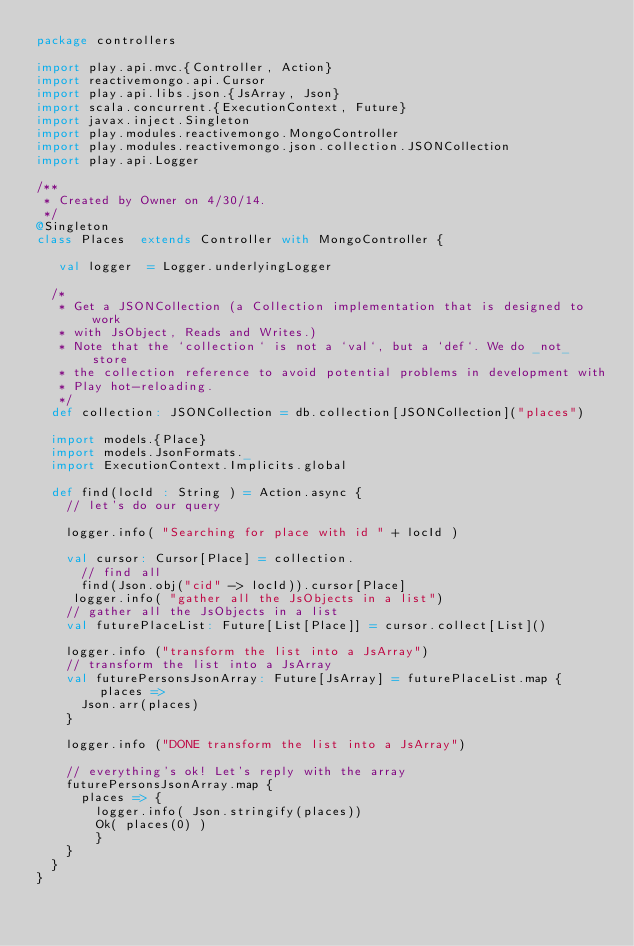Convert code to text. <code><loc_0><loc_0><loc_500><loc_500><_Scala_>package controllers

import play.api.mvc.{Controller, Action}
import reactivemongo.api.Cursor
import play.api.libs.json.{JsArray, Json}
import scala.concurrent.{ExecutionContext, Future}
import javax.inject.Singleton
import play.modules.reactivemongo.MongoController
import play.modules.reactivemongo.json.collection.JSONCollection
import play.api.Logger

/**
 * Created by Owner on 4/30/14.
 */
@Singleton
class Places  extends Controller with MongoController {

   val logger  = Logger.underlyingLogger

  /*
   * Get a JSONCollection (a Collection implementation that is designed to work
   * with JsObject, Reads and Writes.)
   * Note that the `collection` is not a `val`, but a `def`. We do _not_ store
   * the collection reference to avoid potential problems in development with
   * Play hot-reloading.
   */
  def collection: JSONCollection = db.collection[JSONCollection]("places")

  import models.{Place}
  import models.JsonFormats._
  import ExecutionContext.Implicits.global

  def find(locId : String ) = Action.async {
    // let's do our query

    logger.info( "Searching for place with id " + locId )

    val cursor: Cursor[Place] = collection.
      // find all
      find(Json.obj("cid" -> locId)).cursor[Place]
     logger.info( "gather all the JsObjects in a list")
    // gather all the JsObjects in a list
    val futurePlaceList: Future[List[Place]] = cursor.collect[List]()

    logger.info ("transform the list into a JsArray")
    // transform the list into a JsArray
    val futurePersonsJsonArray: Future[JsArray] = futurePlaceList.map { places =>
      Json.arr(places)
    }

    logger.info ("DONE transform the list into a JsArray")

    // everything's ok! Let's reply with the array
    futurePersonsJsonArray.map {
      places => {
        logger.info( Json.stringify(places))
        Ok( places(0) )
        }
    }
  }
}
</code> 